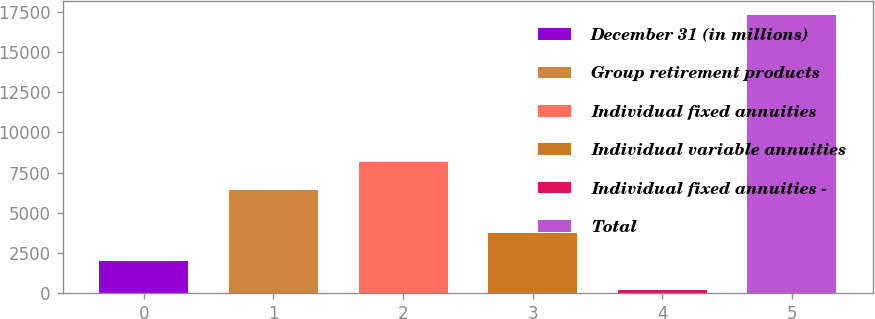<chart> <loc_0><loc_0><loc_500><loc_500><bar_chart><fcel>December 31 (in millions)<fcel>Group retirement products<fcel>Individual fixed annuities<fcel>Individual variable annuities<fcel>Individual fixed annuities -<fcel>Total<nl><fcel>2005<fcel>6436<fcel>8145.2<fcel>3714.2<fcel>200<fcel>17292<nl></chart> 